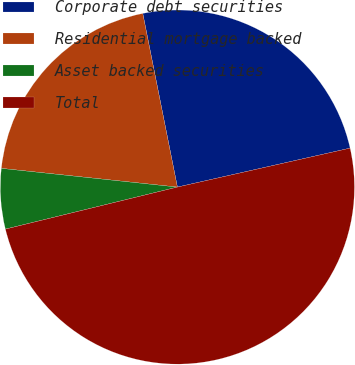<chart> <loc_0><loc_0><loc_500><loc_500><pie_chart><fcel>Corporate debt securities<fcel>Residential mortgage backed<fcel>Asset backed securities<fcel>Total<nl><fcel>24.6%<fcel>20.18%<fcel>5.5%<fcel>49.71%<nl></chart> 